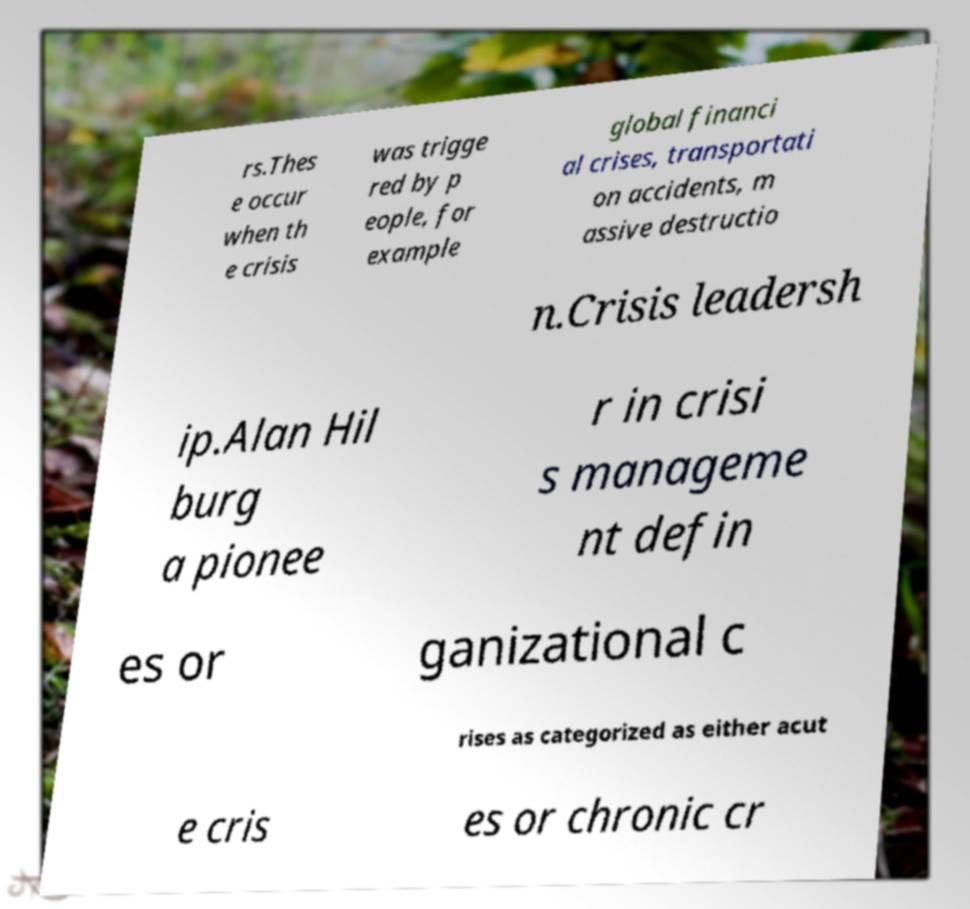I need the written content from this picture converted into text. Can you do that? rs.Thes e occur when th e crisis was trigge red by p eople, for example global financi al crises, transportati on accidents, m assive destructio n.Crisis leadersh ip.Alan Hil burg a pionee r in crisi s manageme nt defin es or ganizational c rises as categorized as either acut e cris es or chronic cr 